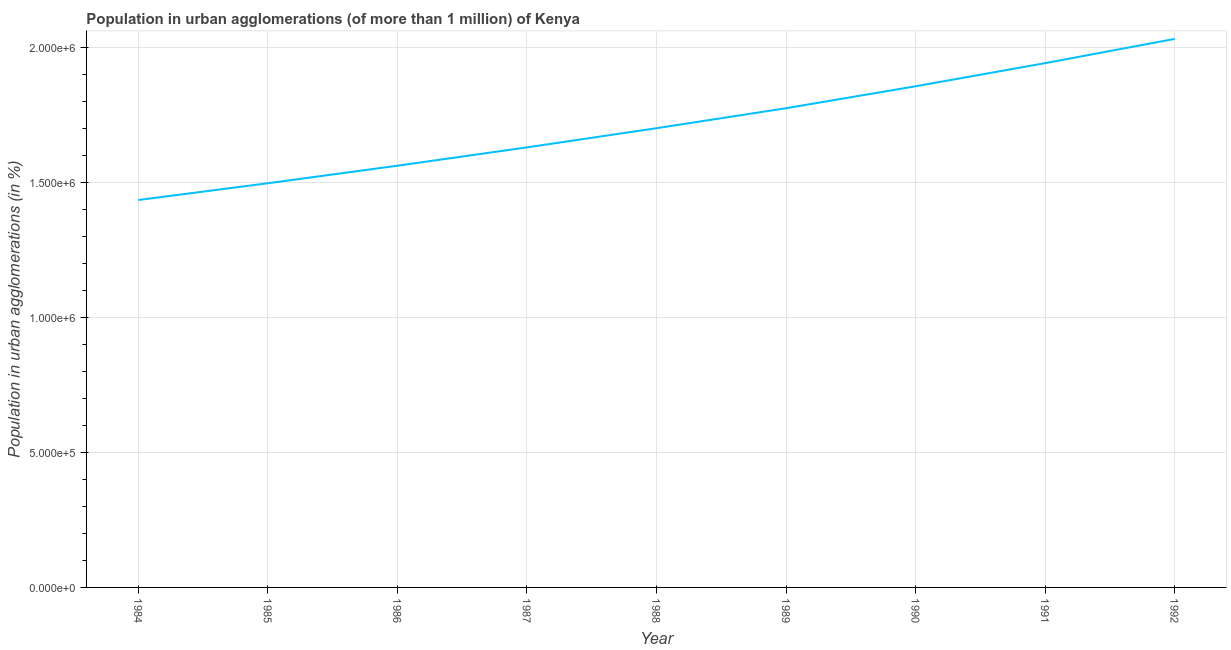What is the population in urban agglomerations in 1991?
Give a very brief answer. 1.94e+06. Across all years, what is the maximum population in urban agglomerations?
Provide a short and direct response. 2.03e+06. Across all years, what is the minimum population in urban agglomerations?
Provide a short and direct response. 1.44e+06. In which year was the population in urban agglomerations minimum?
Your answer should be compact. 1984. What is the sum of the population in urban agglomerations?
Your answer should be compact. 1.54e+07. What is the difference between the population in urban agglomerations in 1984 and 1986?
Your answer should be compact. -1.27e+05. What is the average population in urban agglomerations per year?
Your answer should be compact. 1.71e+06. What is the median population in urban agglomerations?
Offer a very short reply. 1.70e+06. In how many years, is the population in urban agglomerations greater than 300000 %?
Your answer should be compact. 9. Do a majority of the years between 1986 and 1984 (inclusive) have population in urban agglomerations greater than 1500000 %?
Make the answer very short. No. What is the ratio of the population in urban agglomerations in 1984 to that in 1989?
Ensure brevity in your answer.  0.81. What is the difference between the highest and the second highest population in urban agglomerations?
Provide a short and direct response. 8.99e+04. What is the difference between the highest and the lowest population in urban agglomerations?
Give a very brief answer. 5.97e+05. In how many years, is the population in urban agglomerations greater than the average population in urban agglomerations taken over all years?
Offer a very short reply. 4. Does the population in urban agglomerations monotonically increase over the years?
Provide a short and direct response. Yes. How many lines are there?
Offer a very short reply. 1. What is the difference between two consecutive major ticks on the Y-axis?
Provide a succinct answer. 5.00e+05. Are the values on the major ticks of Y-axis written in scientific E-notation?
Ensure brevity in your answer.  Yes. What is the title of the graph?
Make the answer very short. Population in urban agglomerations (of more than 1 million) of Kenya. What is the label or title of the Y-axis?
Ensure brevity in your answer.  Population in urban agglomerations (in %). What is the Population in urban agglomerations (in %) in 1984?
Provide a succinct answer. 1.44e+06. What is the Population in urban agglomerations (in %) in 1985?
Ensure brevity in your answer.  1.50e+06. What is the Population in urban agglomerations (in %) of 1986?
Your response must be concise. 1.56e+06. What is the Population in urban agglomerations (in %) in 1987?
Your answer should be compact. 1.63e+06. What is the Population in urban agglomerations (in %) of 1988?
Make the answer very short. 1.70e+06. What is the Population in urban agglomerations (in %) of 1989?
Provide a short and direct response. 1.78e+06. What is the Population in urban agglomerations (in %) in 1990?
Your answer should be compact. 1.86e+06. What is the Population in urban agglomerations (in %) in 1991?
Your response must be concise. 1.94e+06. What is the Population in urban agglomerations (in %) in 1992?
Your answer should be compact. 2.03e+06. What is the difference between the Population in urban agglomerations (in %) in 1984 and 1985?
Provide a short and direct response. -6.21e+04. What is the difference between the Population in urban agglomerations (in %) in 1984 and 1986?
Offer a terse response. -1.27e+05. What is the difference between the Population in urban agglomerations (in %) in 1984 and 1987?
Keep it short and to the point. -1.95e+05. What is the difference between the Population in urban agglomerations (in %) in 1984 and 1988?
Ensure brevity in your answer.  -2.66e+05. What is the difference between the Population in urban agglomerations (in %) in 1984 and 1989?
Provide a short and direct response. -3.40e+05. What is the difference between the Population in urban agglomerations (in %) in 1984 and 1990?
Keep it short and to the point. -4.21e+05. What is the difference between the Population in urban agglomerations (in %) in 1984 and 1991?
Your answer should be compact. -5.07e+05. What is the difference between the Population in urban agglomerations (in %) in 1984 and 1992?
Offer a very short reply. -5.97e+05. What is the difference between the Population in urban agglomerations (in %) in 1985 and 1986?
Your response must be concise. -6.50e+04. What is the difference between the Population in urban agglomerations (in %) in 1985 and 1987?
Provide a short and direct response. -1.33e+05. What is the difference between the Population in urban agglomerations (in %) in 1985 and 1988?
Make the answer very short. -2.04e+05. What is the difference between the Population in urban agglomerations (in %) in 1985 and 1989?
Offer a terse response. -2.78e+05. What is the difference between the Population in urban agglomerations (in %) in 1985 and 1990?
Provide a short and direct response. -3.59e+05. What is the difference between the Population in urban agglomerations (in %) in 1985 and 1991?
Your response must be concise. -4.45e+05. What is the difference between the Population in urban agglomerations (in %) in 1985 and 1992?
Your answer should be very brief. -5.35e+05. What is the difference between the Population in urban agglomerations (in %) in 1986 and 1987?
Offer a terse response. -6.79e+04. What is the difference between the Population in urban agglomerations (in %) in 1986 and 1988?
Offer a terse response. -1.39e+05. What is the difference between the Population in urban agglomerations (in %) in 1986 and 1989?
Your answer should be compact. -2.13e+05. What is the difference between the Population in urban agglomerations (in %) in 1986 and 1990?
Your response must be concise. -2.94e+05. What is the difference between the Population in urban agglomerations (in %) in 1986 and 1991?
Provide a short and direct response. -3.80e+05. What is the difference between the Population in urban agglomerations (in %) in 1986 and 1992?
Give a very brief answer. -4.70e+05. What is the difference between the Population in urban agglomerations (in %) in 1987 and 1988?
Your answer should be compact. -7.10e+04. What is the difference between the Population in urban agglomerations (in %) in 1987 and 1989?
Ensure brevity in your answer.  -1.45e+05. What is the difference between the Population in urban agglomerations (in %) in 1987 and 1990?
Provide a succinct answer. -2.26e+05. What is the difference between the Population in urban agglomerations (in %) in 1987 and 1991?
Your answer should be very brief. -3.12e+05. What is the difference between the Population in urban agglomerations (in %) in 1987 and 1992?
Provide a succinct answer. -4.02e+05. What is the difference between the Population in urban agglomerations (in %) in 1988 and 1989?
Your response must be concise. -7.40e+04. What is the difference between the Population in urban agglomerations (in %) in 1988 and 1990?
Your answer should be compact. -1.55e+05. What is the difference between the Population in urban agglomerations (in %) in 1988 and 1991?
Your answer should be compact. -2.41e+05. What is the difference between the Population in urban agglomerations (in %) in 1988 and 1992?
Provide a short and direct response. -3.31e+05. What is the difference between the Population in urban agglomerations (in %) in 1989 and 1990?
Ensure brevity in your answer.  -8.13e+04. What is the difference between the Population in urban agglomerations (in %) in 1989 and 1991?
Provide a short and direct response. -1.67e+05. What is the difference between the Population in urban agglomerations (in %) in 1989 and 1992?
Ensure brevity in your answer.  -2.57e+05. What is the difference between the Population in urban agglomerations (in %) in 1990 and 1991?
Provide a succinct answer. -8.57e+04. What is the difference between the Population in urban agglomerations (in %) in 1990 and 1992?
Your answer should be very brief. -1.76e+05. What is the difference between the Population in urban agglomerations (in %) in 1991 and 1992?
Provide a short and direct response. -8.99e+04. What is the ratio of the Population in urban agglomerations (in %) in 1984 to that in 1986?
Provide a short and direct response. 0.92. What is the ratio of the Population in urban agglomerations (in %) in 1984 to that in 1987?
Offer a terse response. 0.88. What is the ratio of the Population in urban agglomerations (in %) in 1984 to that in 1988?
Make the answer very short. 0.84. What is the ratio of the Population in urban agglomerations (in %) in 1984 to that in 1989?
Provide a short and direct response. 0.81. What is the ratio of the Population in urban agglomerations (in %) in 1984 to that in 1990?
Your response must be concise. 0.77. What is the ratio of the Population in urban agglomerations (in %) in 1984 to that in 1991?
Provide a succinct answer. 0.74. What is the ratio of the Population in urban agglomerations (in %) in 1984 to that in 1992?
Your answer should be very brief. 0.71. What is the ratio of the Population in urban agglomerations (in %) in 1985 to that in 1986?
Give a very brief answer. 0.96. What is the ratio of the Population in urban agglomerations (in %) in 1985 to that in 1987?
Provide a succinct answer. 0.92. What is the ratio of the Population in urban agglomerations (in %) in 1985 to that in 1989?
Provide a succinct answer. 0.84. What is the ratio of the Population in urban agglomerations (in %) in 1985 to that in 1990?
Your response must be concise. 0.81. What is the ratio of the Population in urban agglomerations (in %) in 1985 to that in 1991?
Give a very brief answer. 0.77. What is the ratio of the Population in urban agglomerations (in %) in 1985 to that in 1992?
Your answer should be very brief. 0.74. What is the ratio of the Population in urban agglomerations (in %) in 1986 to that in 1987?
Your answer should be very brief. 0.96. What is the ratio of the Population in urban agglomerations (in %) in 1986 to that in 1988?
Provide a short and direct response. 0.92. What is the ratio of the Population in urban agglomerations (in %) in 1986 to that in 1990?
Provide a succinct answer. 0.84. What is the ratio of the Population in urban agglomerations (in %) in 1986 to that in 1991?
Offer a terse response. 0.8. What is the ratio of the Population in urban agglomerations (in %) in 1986 to that in 1992?
Your response must be concise. 0.77. What is the ratio of the Population in urban agglomerations (in %) in 1987 to that in 1988?
Make the answer very short. 0.96. What is the ratio of the Population in urban agglomerations (in %) in 1987 to that in 1989?
Offer a very short reply. 0.92. What is the ratio of the Population in urban agglomerations (in %) in 1987 to that in 1990?
Offer a terse response. 0.88. What is the ratio of the Population in urban agglomerations (in %) in 1987 to that in 1991?
Ensure brevity in your answer.  0.84. What is the ratio of the Population in urban agglomerations (in %) in 1987 to that in 1992?
Provide a short and direct response. 0.8. What is the ratio of the Population in urban agglomerations (in %) in 1988 to that in 1989?
Offer a terse response. 0.96. What is the ratio of the Population in urban agglomerations (in %) in 1988 to that in 1990?
Ensure brevity in your answer.  0.92. What is the ratio of the Population in urban agglomerations (in %) in 1988 to that in 1991?
Your answer should be very brief. 0.88. What is the ratio of the Population in urban agglomerations (in %) in 1988 to that in 1992?
Give a very brief answer. 0.84. What is the ratio of the Population in urban agglomerations (in %) in 1989 to that in 1990?
Give a very brief answer. 0.96. What is the ratio of the Population in urban agglomerations (in %) in 1989 to that in 1991?
Ensure brevity in your answer.  0.91. What is the ratio of the Population in urban agglomerations (in %) in 1989 to that in 1992?
Keep it short and to the point. 0.87. What is the ratio of the Population in urban agglomerations (in %) in 1990 to that in 1991?
Your response must be concise. 0.96. What is the ratio of the Population in urban agglomerations (in %) in 1990 to that in 1992?
Provide a succinct answer. 0.91. What is the ratio of the Population in urban agglomerations (in %) in 1991 to that in 1992?
Keep it short and to the point. 0.96. 